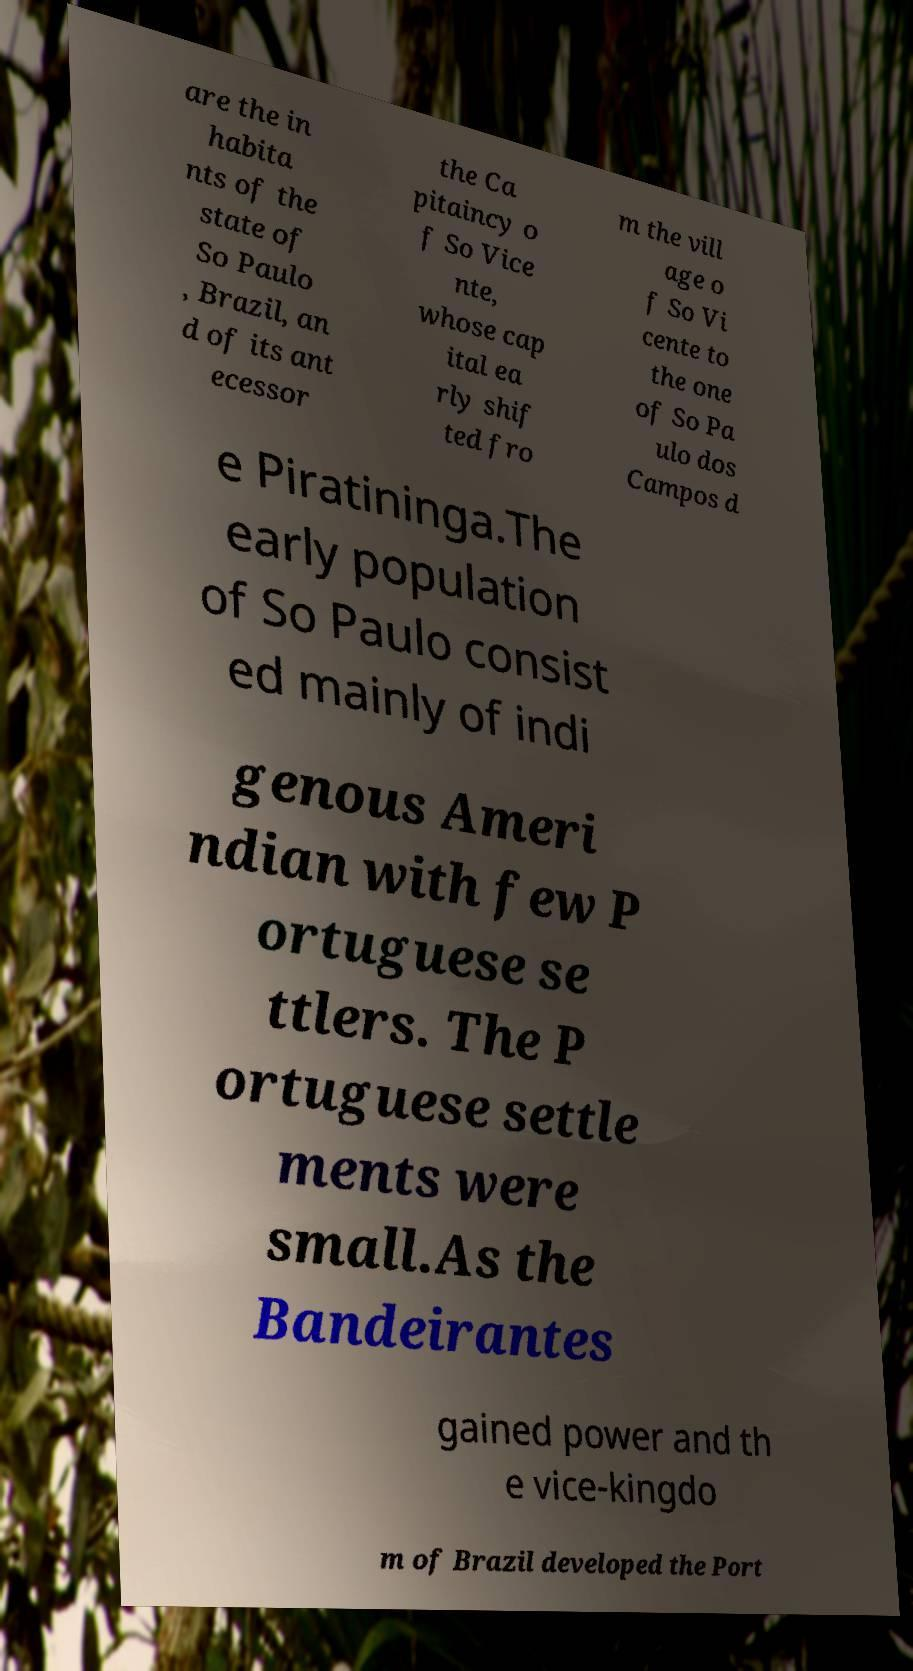Could you assist in decoding the text presented in this image and type it out clearly? are the in habita nts of the state of So Paulo , Brazil, an d of its ant ecessor the Ca pitaincy o f So Vice nte, whose cap ital ea rly shif ted fro m the vill age o f So Vi cente to the one of So Pa ulo dos Campos d e Piratininga.The early population of So Paulo consist ed mainly of indi genous Ameri ndian with few P ortuguese se ttlers. The P ortuguese settle ments were small.As the Bandeirantes gained power and th e vice-kingdo m of Brazil developed the Port 